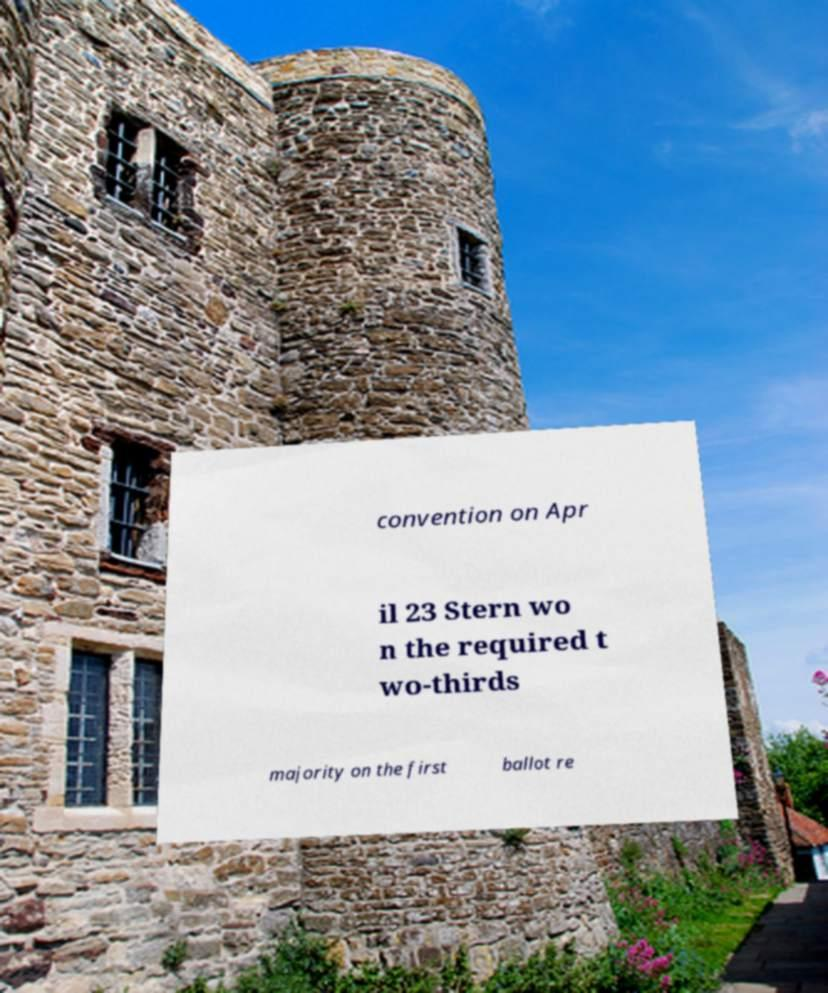Can you read and provide the text displayed in the image?This photo seems to have some interesting text. Can you extract and type it out for me? convention on Apr il 23 Stern wo n the required t wo-thirds majority on the first ballot re 